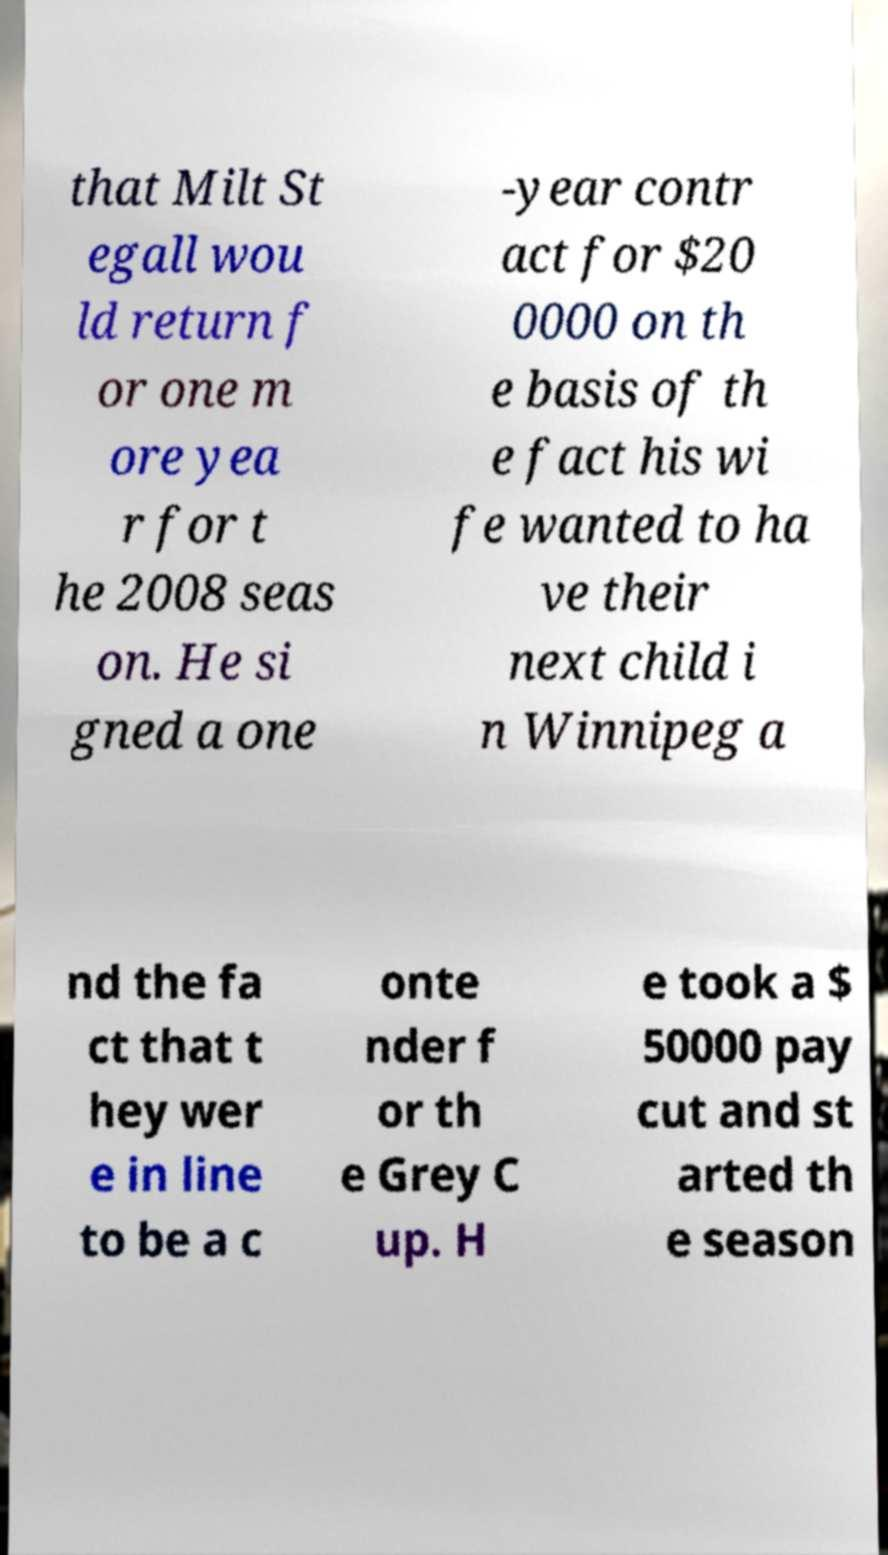Please read and relay the text visible in this image. What does it say? that Milt St egall wou ld return f or one m ore yea r for t he 2008 seas on. He si gned a one -year contr act for $20 0000 on th e basis of th e fact his wi fe wanted to ha ve their next child i n Winnipeg a nd the fa ct that t hey wer e in line to be a c onte nder f or th e Grey C up. H e took a $ 50000 pay cut and st arted th e season 